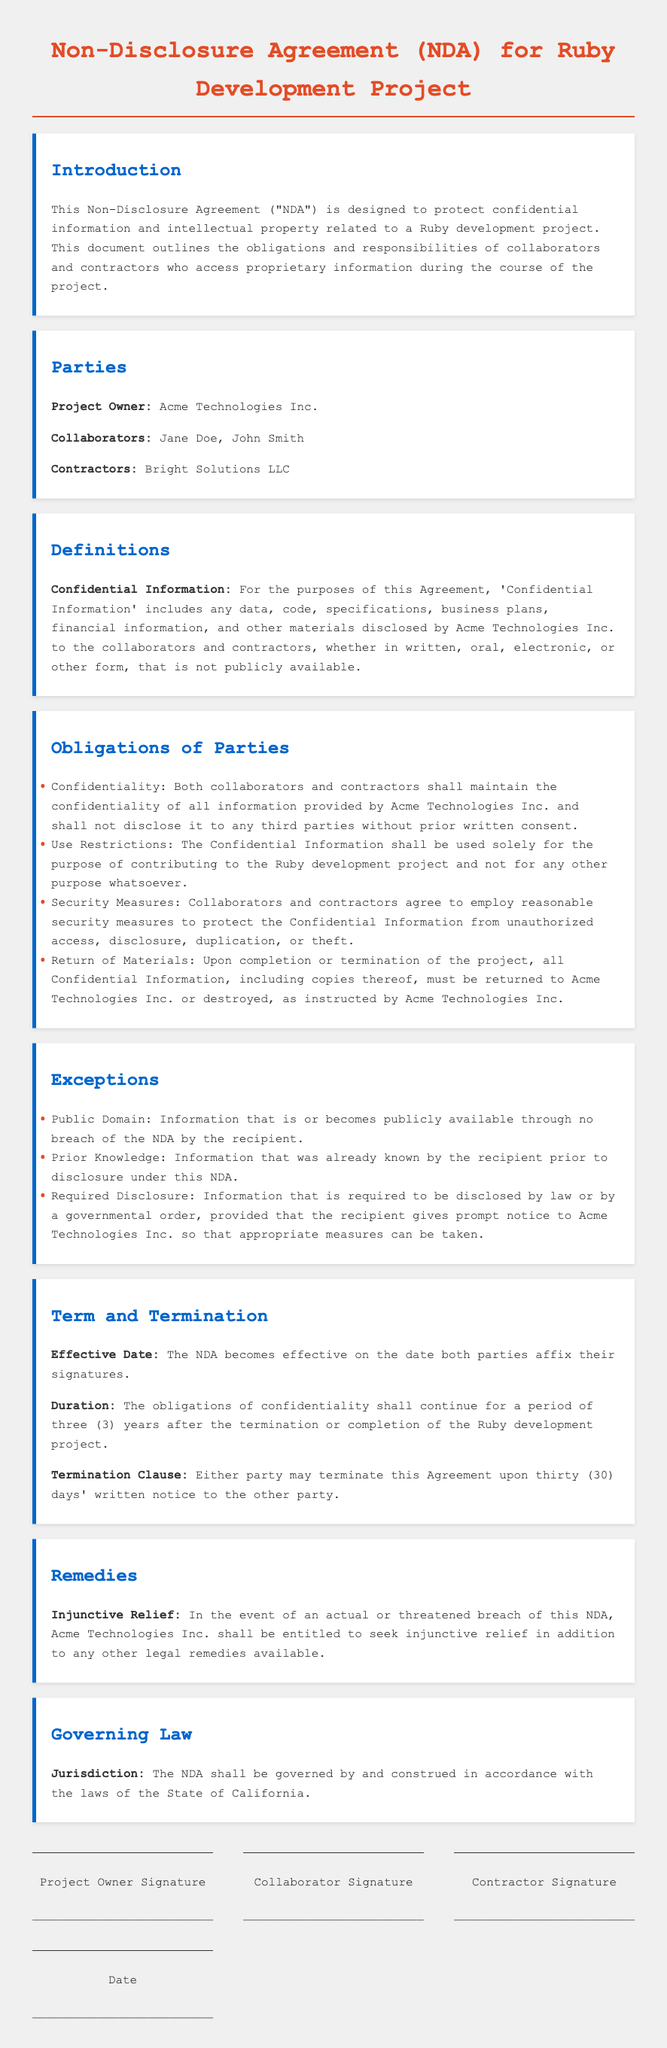What is the effective date of the NDA? The effective date of the NDA is when both parties affix their signatures.
Answer: when both parties affix their signatures Who is the project owner? The document states that Acme Technologies Inc. is the project owner.
Answer: Acme Technologies Inc How long do confidentiality obligations last after project completion? The document specifies that obligations of confidentiality shall continue for three years after project completion.
Answer: three years What must be done with confidential information upon project completion? The NDA states that all Confidential Information must be returned or destroyed as instructed.
Answer: returned or destroyed What type of relief may Acme Technologies Inc. seek in case of a breach? The document mentions that Acme Technologies Inc. may seek injunctive relief.
Answer: injunctive relief What is classified as Confidential Information? Confidential Information includes any data, code, specifications, and business plans disclosed by Acme Technologies Inc.
Answer: data, code, specifications, and business plans How many collaborators are listed in the NDA? The NDA names two collaborators: Jane Doe and John Smith.
Answer: two collaborators What is the governing law for the NDA? The document states that the NDA shall be governed by the laws of the State of California.
Answer: State of California 